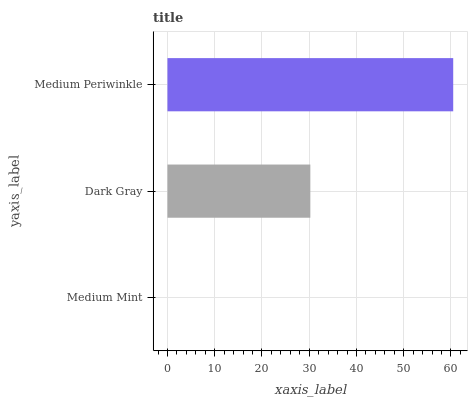Is Medium Mint the minimum?
Answer yes or no. Yes. Is Medium Periwinkle the maximum?
Answer yes or no. Yes. Is Dark Gray the minimum?
Answer yes or no. No. Is Dark Gray the maximum?
Answer yes or no. No. Is Dark Gray greater than Medium Mint?
Answer yes or no. Yes. Is Medium Mint less than Dark Gray?
Answer yes or no. Yes. Is Medium Mint greater than Dark Gray?
Answer yes or no. No. Is Dark Gray less than Medium Mint?
Answer yes or no. No. Is Dark Gray the high median?
Answer yes or no. Yes. Is Dark Gray the low median?
Answer yes or no. Yes. Is Medium Mint the high median?
Answer yes or no. No. Is Medium Periwinkle the low median?
Answer yes or no. No. 